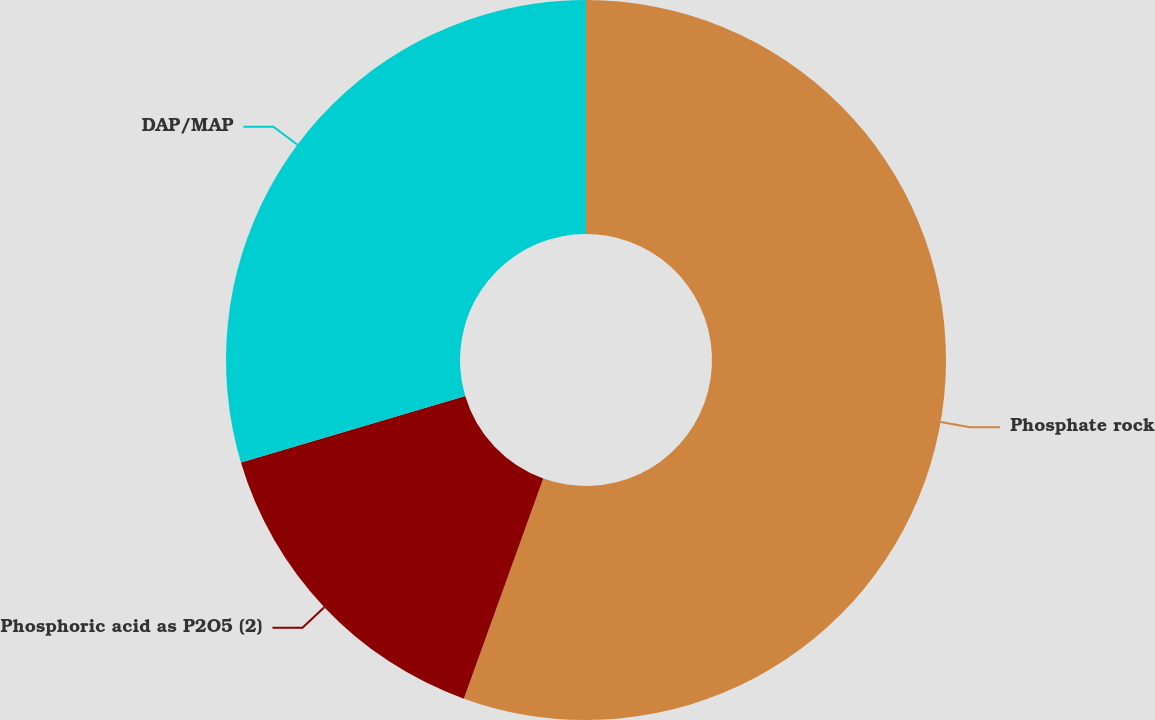Convert chart to OTSL. <chart><loc_0><loc_0><loc_500><loc_500><pie_chart><fcel>Phosphate rock<fcel>Phosphoric acid as P2O5 (2)<fcel>DAP/MAP<nl><fcel>55.51%<fcel>14.89%<fcel>29.6%<nl></chart> 